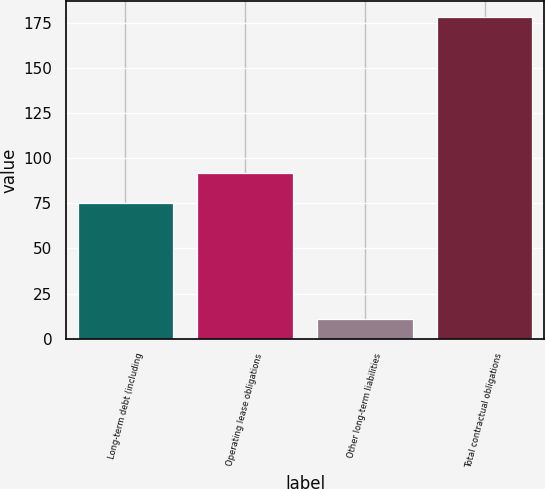<chart> <loc_0><loc_0><loc_500><loc_500><bar_chart><fcel>Long-term debt (including<fcel>Operating lease obligations<fcel>Other long-term liabilities<fcel>Total contractual obligations<nl><fcel>75<fcel>91.7<fcel>11<fcel>178<nl></chart> 